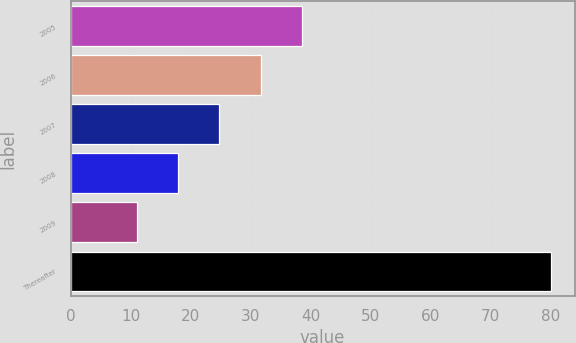Convert chart to OTSL. <chart><loc_0><loc_0><loc_500><loc_500><bar_chart><fcel>2005<fcel>2006<fcel>2007<fcel>2008<fcel>2009<fcel>Thereafter<nl><fcel>38.6<fcel>31.7<fcel>24.8<fcel>17.9<fcel>11<fcel>80<nl></chart> 